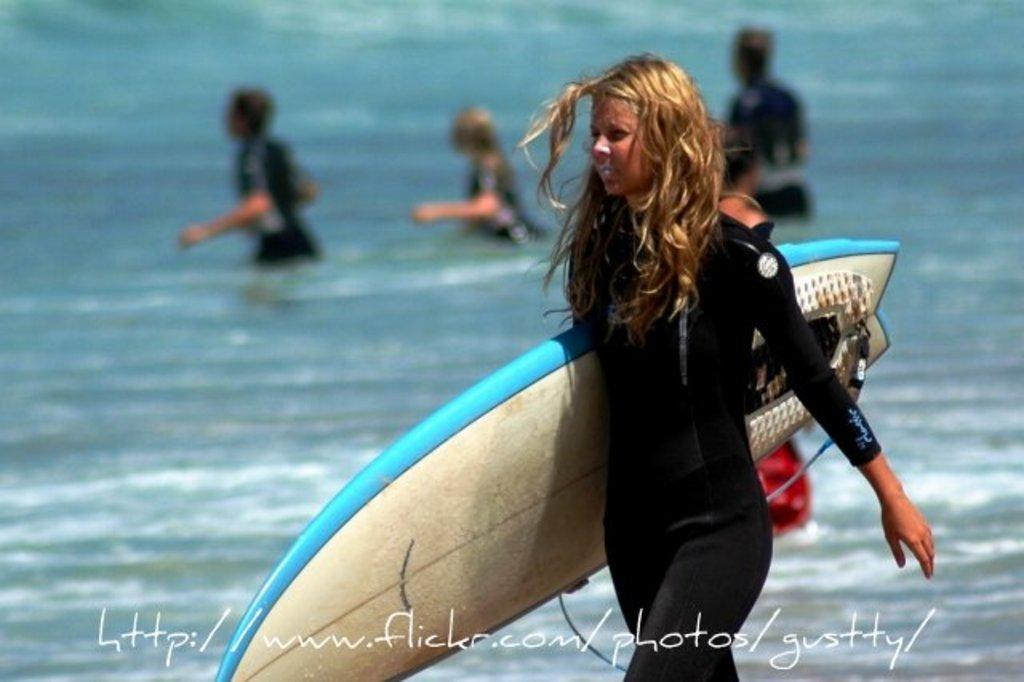Who is the main subject in the image? There is a woman in the image. What is the woman doing in the image? The woman is walking. What is the woman holding in the image? The woman is holding a skateboard. What is the woman wearing in the image? The woman is wearing a suit. What can be seen in the background of the image? There are three people in the water in the background of the image. Where is the sink located in the image? There is no sink present in the image. What type of doll can be seen playing with the skateboard in the image? There is no doll present in the image; the woman is holding the skateboard. 